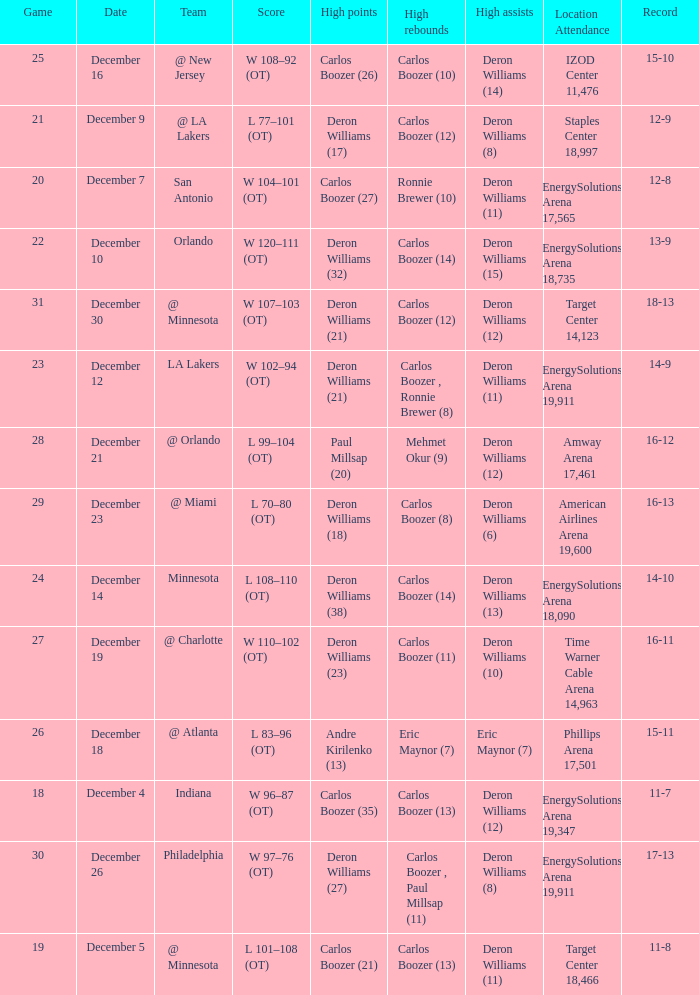How many different high rebound results are there for the game number 26? 1.0. 